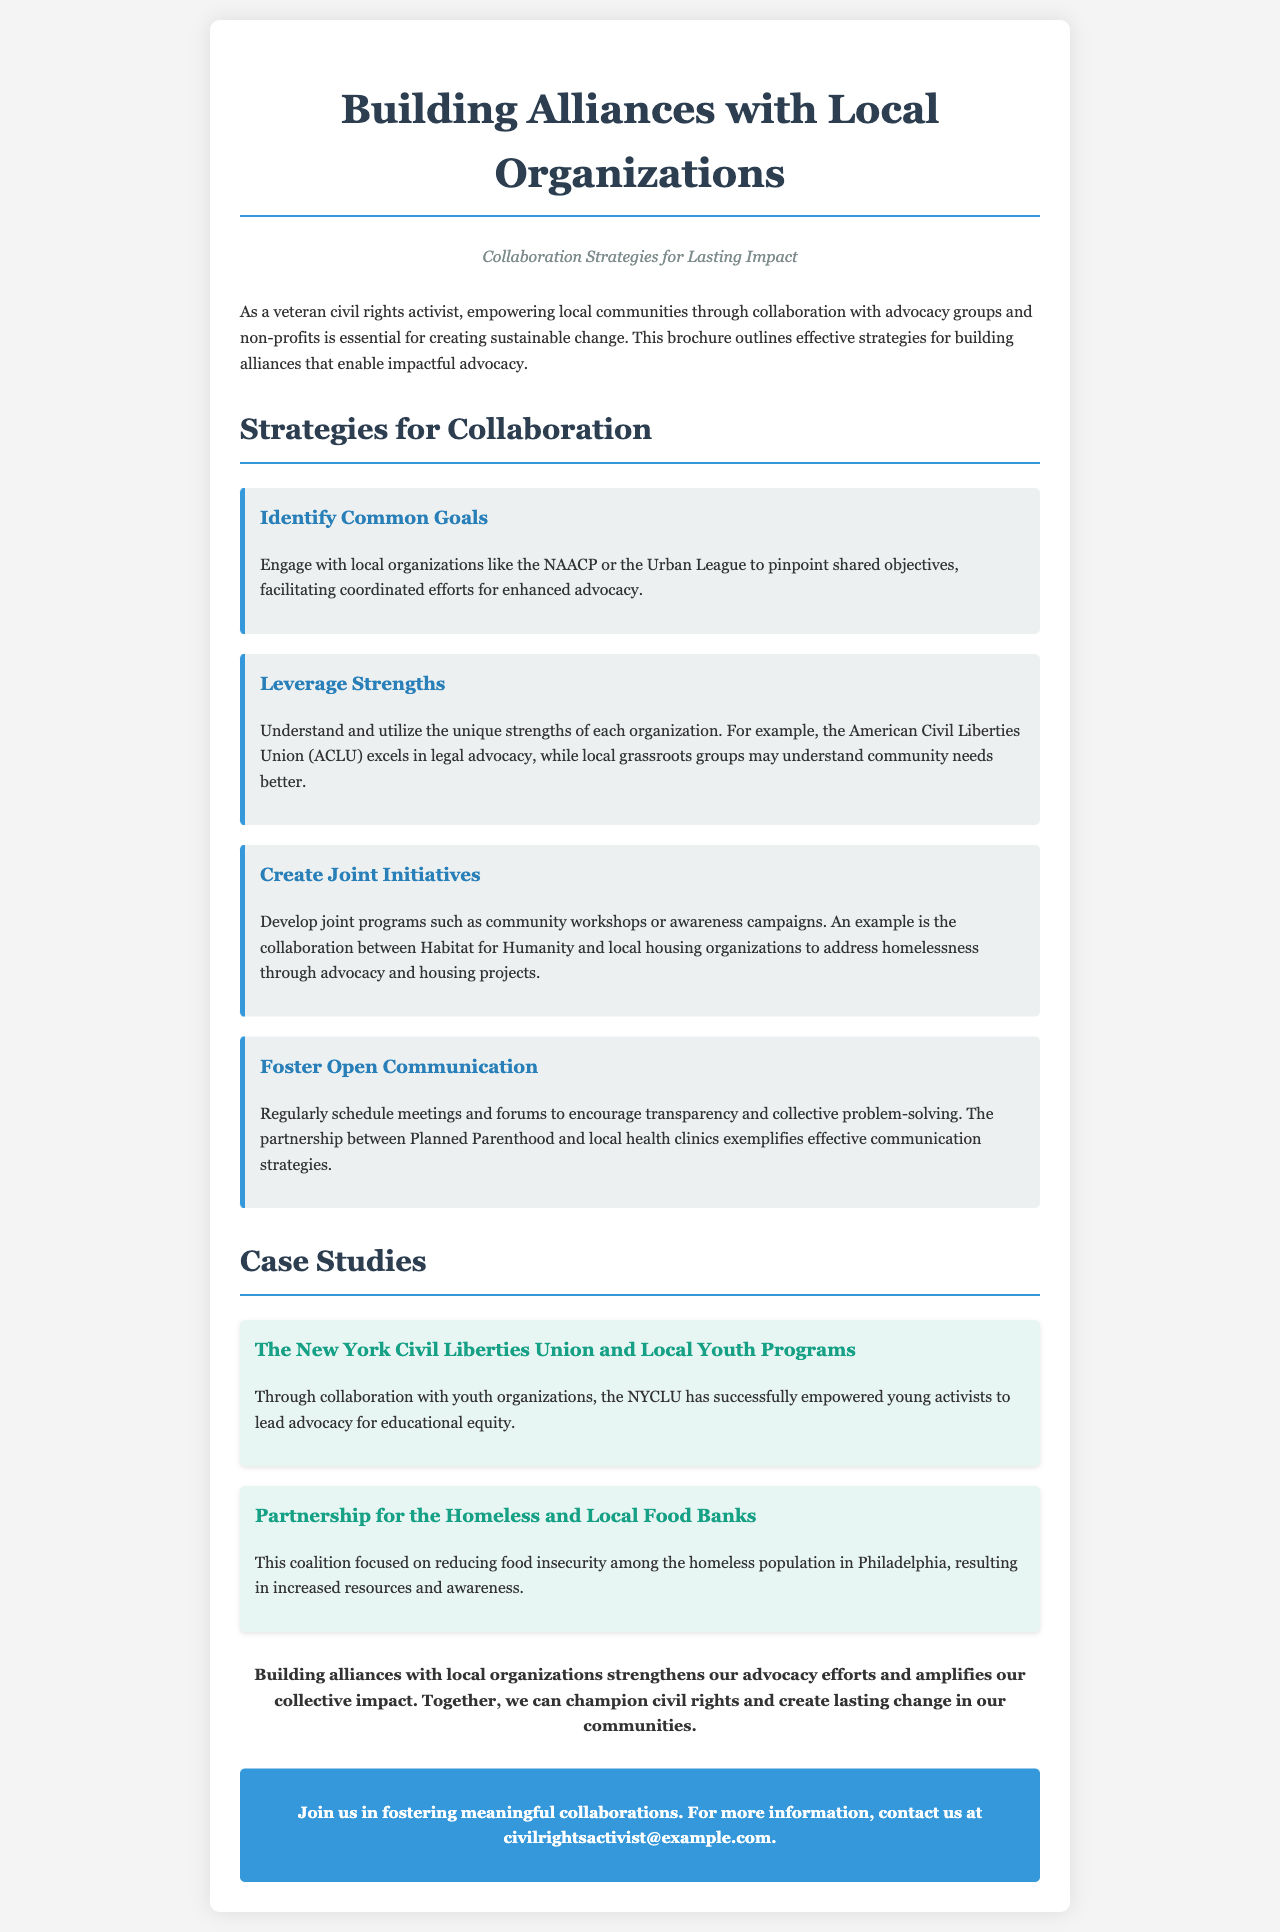What is the title of the brochure? The title is stated prominently at the top of the document.
Answer: Building Alliances with Local Organizations What is the subtitle of the brochure? The subtitle provides additional context and is positioned just below the title.
Answer: Collaboration Strategies for Lasting Impact Which organization is mentioned as an example for identifying common goals? The document lists organizations that could be collaborated with, specifically for identifying common objectives.
Answer: NAACP What is one of the case studies featured in the brochure? The document provides specific examples of successful partnerships showcased under the case studies section.
Answer: The New York Civil Liberties Union and Local Youth Programs What type of initiatives does the brochure suggest creating? The document provides strategies, including the types of projects that can be initiated for collaboration.
Answer: Joint initiatives How does the document suggest fostering communication? The strategies section mentions specific actions to enhance communication among organizations.
Answer: Regularly schedule meetings What is the email mentioned for more information? The document concludes with a prompt for further contact, listing an email address.
Answer: civilrightsactivist@example.com What is the main focus of the brochure? The brochure's introduction clearly describes its central theme.
Answer: Empowering local communities through collaboration How does the brochure suggest leveraging strengths? The document outlines how to utilize the unique abilities of different organizations.
Answer: Understand and utilize the unique strengths 